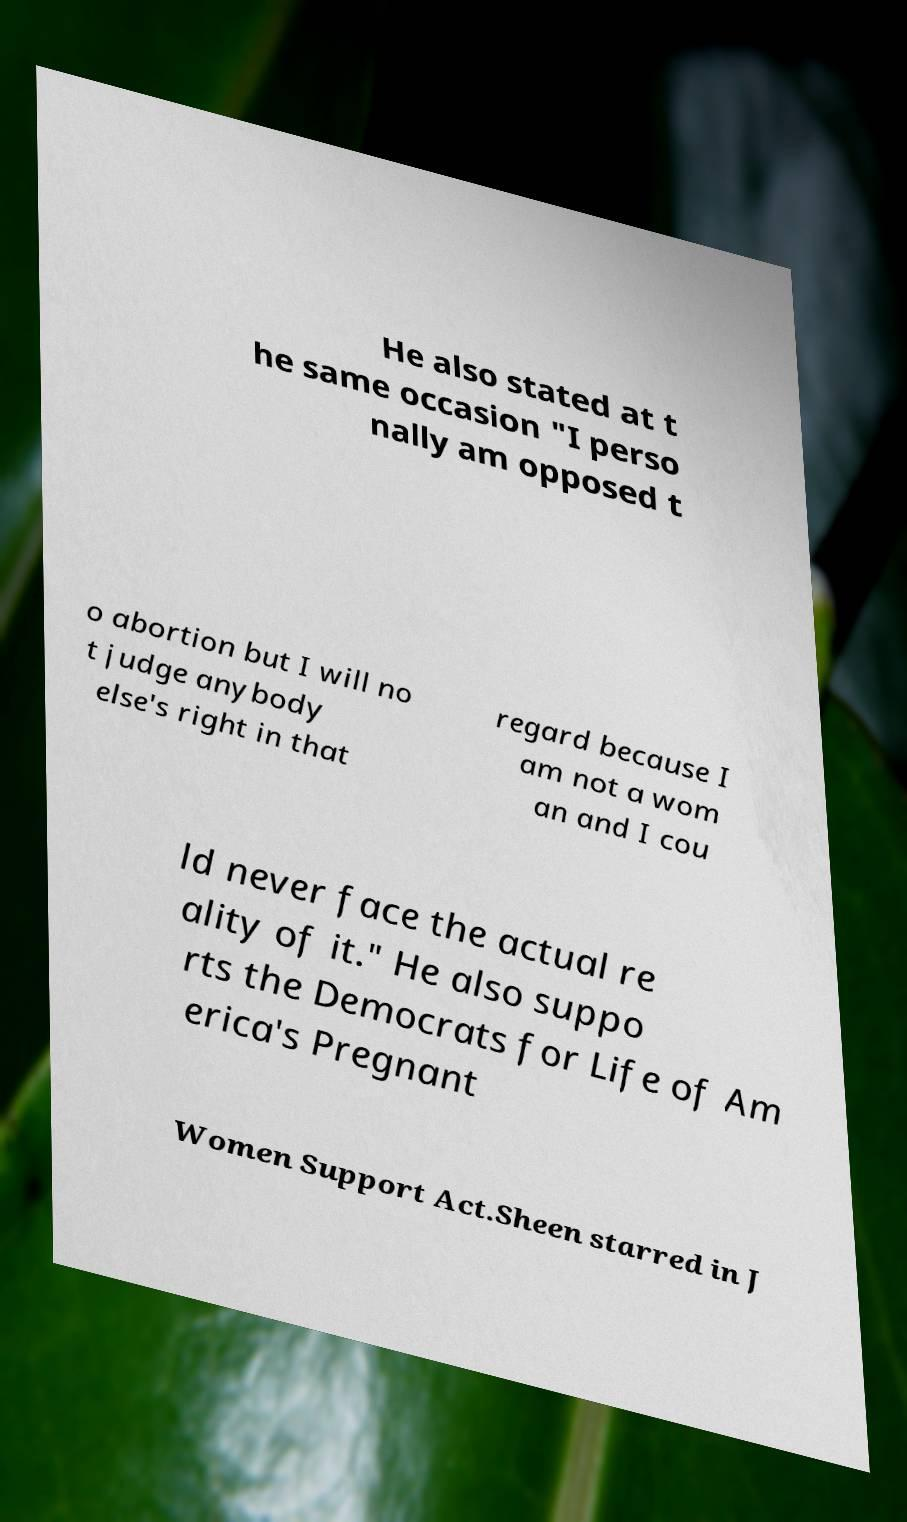There's text embedded in this image that I need extracted. Can you transcribe it verbatim? He also stated at t he same occasion "I perso nally am opposed t o abortion but I will no t judge anybody else's right in that regard because I am not a wom an and I cou ld never face the actual re ality of it." He also suppo rts the Democrats for Life of Am erica's Pregnant Women Support Act.Sheen starred in J 